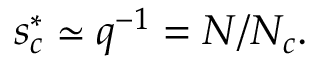<formula> <loc_0><loc_0><loc_500><loc_500>s _ { c } ^ { * } \simeq q ^ { - 1 } = N / N _ { c } .</formula> 